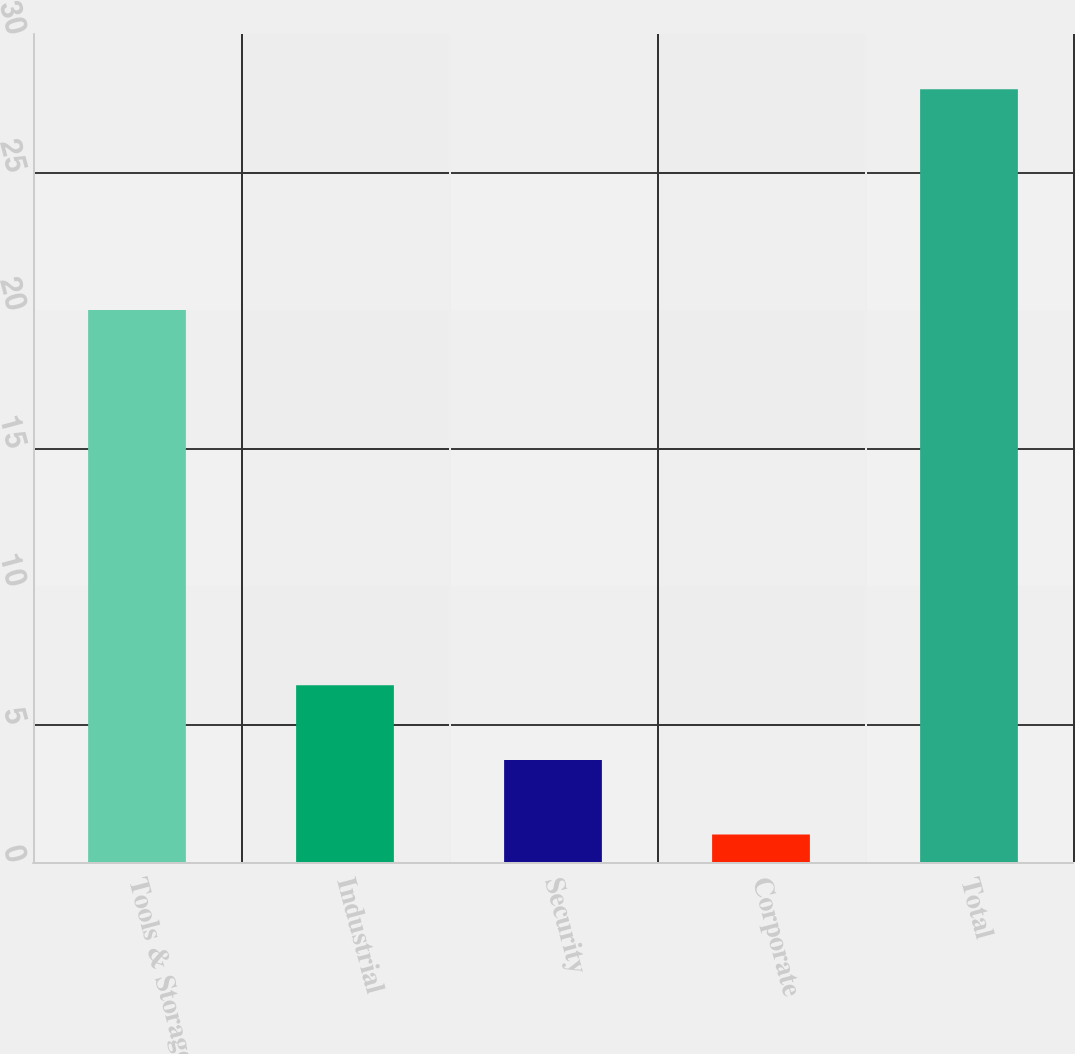Convert chart to OTSL. <chart><loc_0><loc_0><loc_500><loc_500><bar_chart><fcel>Tools & Storage<fcel>Industrial<fcel>Security<fcel>Corporate<fcel>Total<nl><fcel>20<fcel>6.4<fcel>3.7<fcel>1<fcel>28<nl></chart> 